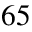Convert formula to latex. <formula><loc_0><loc_0><loc_500><loc_500>6 5</formula> 